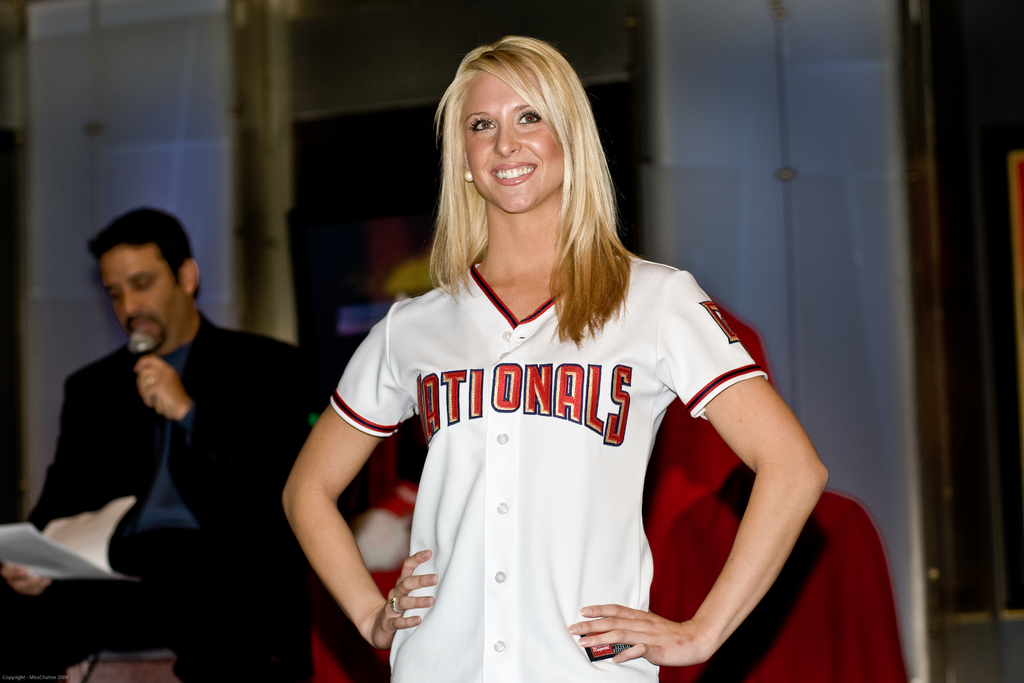What can be inferred about her role or affiliation with the Nationals from her demeanor and attire? Her professional demeanor and attire indicate she could be a spokesperson or a prominent supporter, actively engaging with the audience or fans at an official event. 